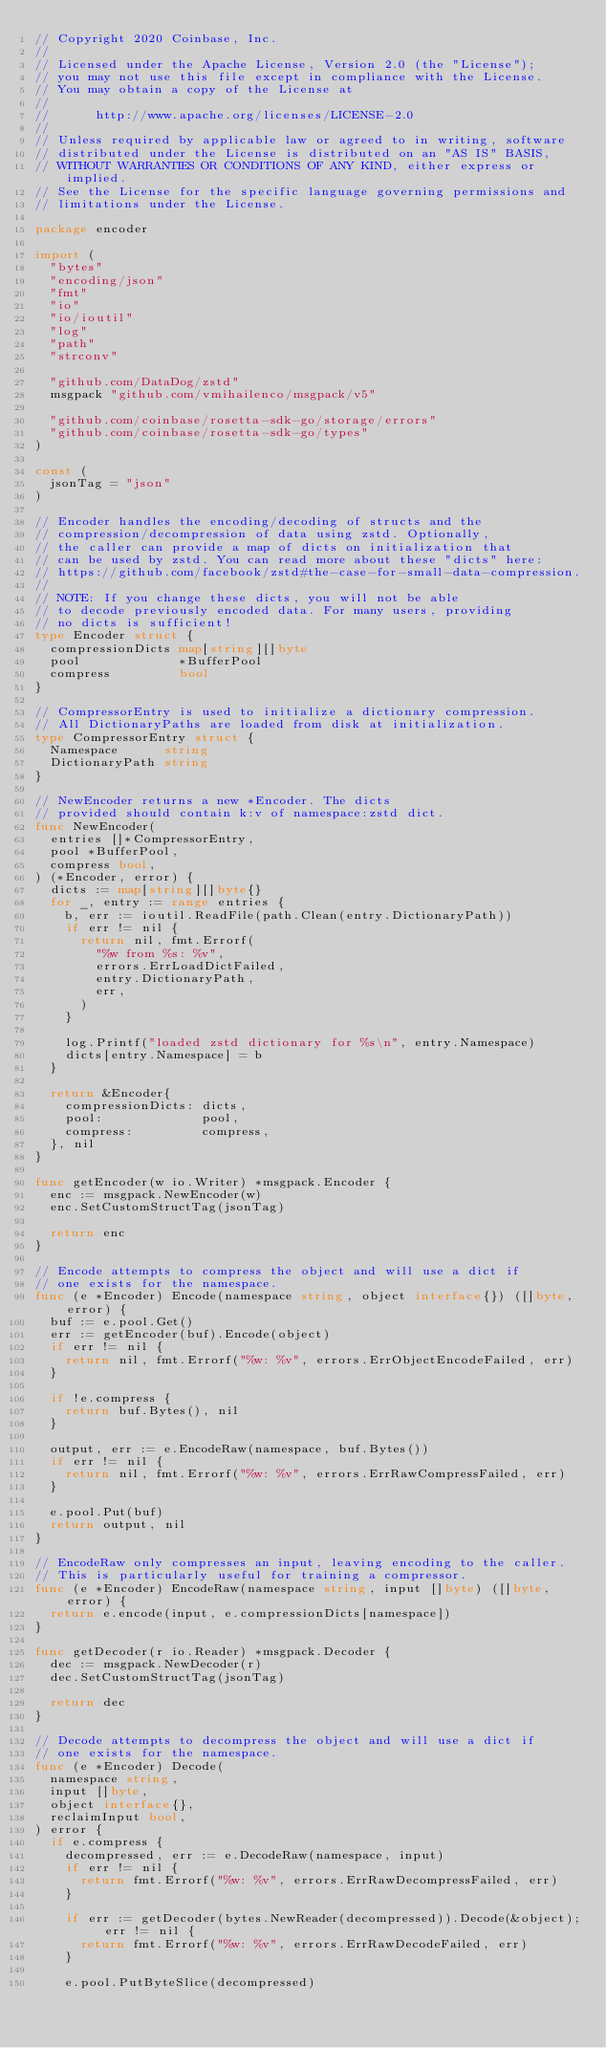Convert code to text. <code><loc_0><loc_0><loc_500><loc_500><_Go_>// Copyright 2020 Coinbase, Inc.
//
// Licensed under the Apache License, Version 2.0 (the "License");
// you may not use this file except in compliance with the License.
// You may obtain a copy of the License at
//
//      http://www.apache.org/licenses/LICENSE-2.0
//
// Unless required by applicable law or agreed to in writing, software
// distributed under the License is distributed on an "AS IS" BASIS,
// WITHOUT WARRANTIES OR CONDITIONS OF ANY KIND, either express or implied.
// See the License for the specific language governing permissions and
// limitations under the License.

package encoder

import (
	"bytes"
	"encoding/json"
	"fmt"
	"io"
	"io/ioutil"
	"log"
	"path"
	"strconv"

	"github.com/DataDog/zstd"
	msgpack "github.com/vmihailenco/msgpack/v5"

	"github.com/coinbase/rosetta-sdk-go/storage/errors"
	"github.com/coinbase/rosetta-sdk-go/types"
)

const (
	jsonTag = "json"
)

// Encoder handles the encoding/decoding of structs and the
// compression/decompression of data using zstd. Optionally,
// the caller can provide a map of dicts on initialization that
// can be used by zstd. You can read more about these "dicts" here:
// https://github.com/facebook/zstd#the-case-for-small-data-compression.
//
// NOTE: If you change these dicts, you will not be able
// to decode previously encoded data. For many users, providing
// no dicts is sufficient!
type Encoder struct {
	compressionDicts map[string][]byte
	pool             *BufferPool
	compress         bool
}

// CompressorEntry is used to initialize a dictionary compression.
// All DictionaryPaths are loaded from disk at initialization.
type CompressorEntry struct {
	Namespace      string
	DictionaryPath string
}

// NewEncoder returns a new *Encoder. The dicts
// provided should contain k:v of namespace:zstd dict.
func NewEncoder(
	entries []*CompressorEntry,
	pool *BufferPool,
	compress bool,
) (*Encoder, error) {
	dicts := map[string][]byte{}
	for _, entry := range entries {
		b, err := ioutil.ReadFile(path.Clean(entry.DictionaryPath))
		if err != nil {
			return nil, fmt.Errorf(
				"%w from %s: %v",
				errors.ErrLoadDictFailed,
				entry.DictionaryPath,
				err,
			)
		}

		log.Printf("loaded zstd dictionary for %s\n", entry.Namespace)
		dicts[entry.Namespace] = b
	}

	return &Encoder{
		compressionDicts: dicts,
		pool:             pool,
		compress:         compress,
	}, nil
}

func getEncoder(w io.Writer) *msgpack.Encoder {
	enc := msgpack.NewEncoder(w)
	enc.SetCustomStructTag(jsonTag)

	return enc
}

// Encode attempts to compress the object and will use a dict if
// one exists for the namespace.
func (e *Encoder) Encode(namespace string, object interface{}) ([]byte, error) {
	buf := e.pool.Get()
	err := getEncoder(buf).Encode(object)
	if err != nil {
		return nil, fmt.Errorf("%w: %v", errors.ErrObjectEncodeFailed, err)
	}

	if !e.compress {
		return buf.Bytes(), nil
	}

	output, err := e.EncodeRaw(namespace, buf.Bytes())
	if err != nil {
		return nil, fmt.Errorf("%w: %v", errors.ErrRawCompressFailed, err)
	}

	e.pool.Put(buf)
	return output, nil
}

// EncodeRaw only compresses an input, leaving encoding to the caller.
// This is particularly useful for training a compressor.
func (e *Encoder) EncodeRaw(namespace string, input []byte) ([]byte, error) {
	return e.encode(input, e.compressionDicts[namespace])
}

func getDecoder(r io.Reader) *msgpack.Decoder {
	dec := msgpack.NewDecoder(r)
	dec.SetCustomStructTag(jsonTag)

	return dec
}

// Decode attempts to decompress the object and will use a dict if
// one exists for the namespace.
func (e *Encoder) Decode(
	namespace string,
	input []byte,
	object interface{},
	reclaimInput bool,
) error {
	if e.compress {
		decompressed, err := e.DecodeRaw(namespace, input)
		if err != nil {
			return fmt.Errorf("%w: %v", errors.ErrRawDecompressFailed, err)
		}

		if err := getDecoder(bytes.NewReader(decompressed)).Decode(&object); err != nil {
			return fmt.Errorf("%w: %v", errors.ErrRawDecodeFailed, err)
		}

		e.pool.PutByteSlice(decompressed)</code> 